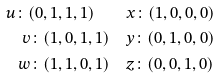Convert formula to latex. <formula><loc_0><loc_0><loc_500><loc_500>u \colon ( 0 , 1 , 1 , 1 ) \quad & x \colon ( 1 , 0 , 0 , 0 ) \\ v \colon ( 1 , 0 , 1 , 1 ) \quad & y \colon ( 0 , 1 , 0 , 0 ) \\ w \colon ( 1 , 1 , 0 , 1 ) \quad & z \colon ( 0 , 0 , 1 , 0 )</formula> 